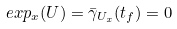Convert formula to latex. <formula><loc_0><loc_0><loc_500><loc_500>e x p _ { x } ( U ) = \bar { \gamma } _ { U _ { x } } ( t _ { f } ) = 0</formula> 